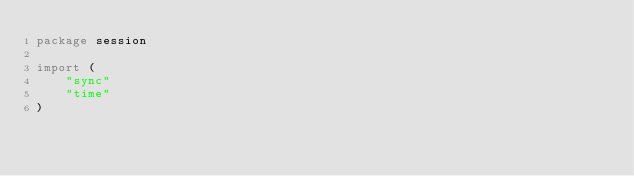<code> <loc_0><loc_0><loc_500><loc_500><_Go_>package session

import (
	"sync"
	"time"
)

</code> 